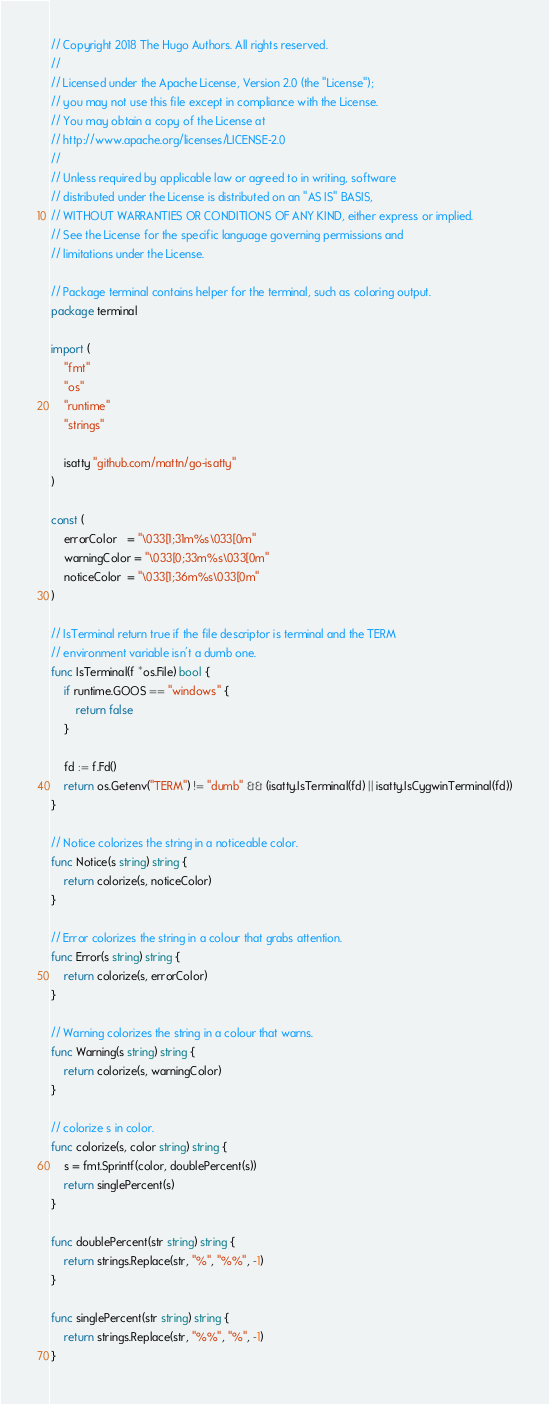Convert code to text. <code><loc_0><loc_0><loc_500><loc_500><_Go_>// Copyright 2018 The Hugo Authors. All rights reserved.
//
// Licensed under the Apache License, Version 2.0 (the "License");
// you may not use this file except in compliance with the License.
// You may obtain a copy of the License at
// http://www.apache.org/licenses/LICENSE-2.0
//
// Unless required by applicable law or agreed to in writing, software
// distributed under the License is distributed on an "AS IS" BASIS,
// WITHOUT WARRANTIES OR CONDITIONS OF ANY KIND, either express or implied.
// See the License for the specific language governing permissions and
// limitations under the License.

// Package terminal contains helper for the terminal, such as coloring output.
package terminal

import (
	"fmt"
	"os"
	"runtime"
	"strings"

	isatty "github.com/mattn/go-isatty"
)

const (
	errorColor   = "\033[1;31m%s\033[0m"
	warningColor = "\033[0;33m%s\033[0m"
	noticeColor  = "\033[1;36m%s\033[0m"
)

// IsTerminal return true if the file descriptor is terminal and the TERM
// environment variable isn't a dumb one.
func IsTerminal(f *os.File) bool {
	if runtime.GOOS == "windows" {
		return false
	}

	fd := f.Fd()
	return os.Getenv("TERM") != "dumb" && (isatty.IsTerminal(fd) || isatty.IsCygwinTerminal(fd))
}

// Notice colorizes the string in a noticeable color.
func Notice(s string) string {
	return colorize(s, noticeColor)
}

// Error colorizes the string in a colour that grabs attention.
func Error(s string) string {
	return colorize(s, errorColor)
}

// Warning colorizes the string in a colour that warns.
func Warning(s string) string {
	return colorize(s, warningColor)
}

// colorize s in color.
func colorize(s, color string) string {
	s = fmt.Sprintf(color, doublePercent(s))
	return singlePercent(s)
}

func doublePercent(str string) string {
	return strings.Replace(str, "%", "%%", -1)
}

func singlePercent(str string) string {
	return strings.Replace(str, "%%", "%", -1)
}
</code> 